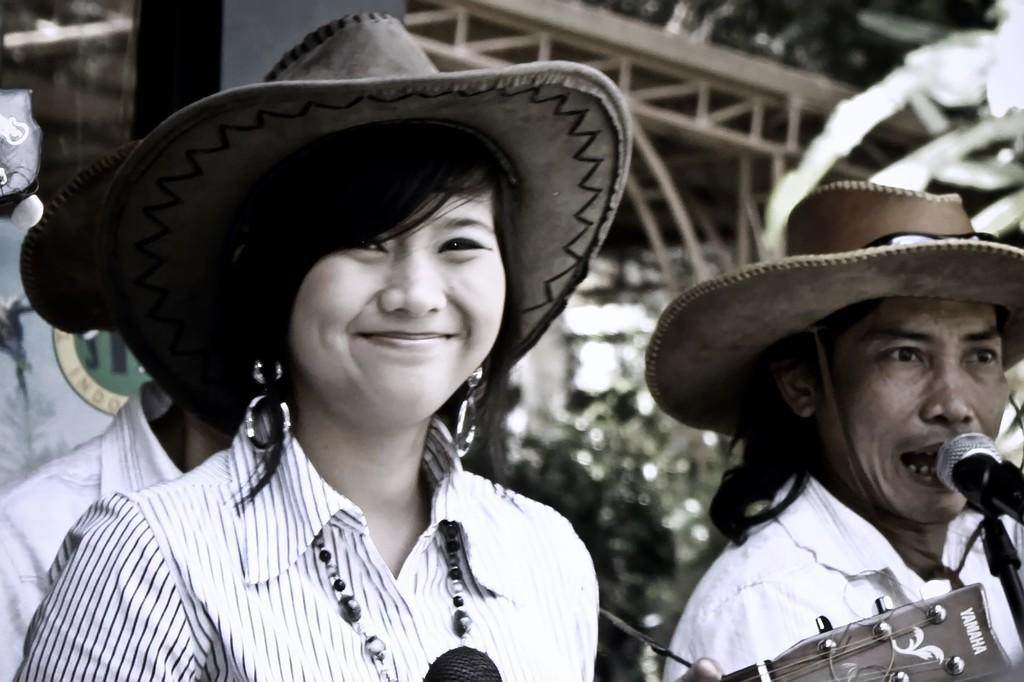How many people are in the image? There are three people in the image. Can you describe the clothing or accessories of one of the people? One person is wearing a hat. What is the other person near in the image? Another person is near a microphone. What type of object is present in the image that might be used for making music? A musical instrument is present in the image. What can be seen in the background of the image? There are trees and other items visible in the background of the image. What type of jam is being spread on the receipt in the image? There is no jam or receipt present in the image. What type of street is visible in the background of the image? There is no street visible in the background of the image; it features trees and other unspecified items. 